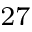<formula> <loc_0><loc_0><loc_500><loc_500>^ { 2 7 }</formula> 